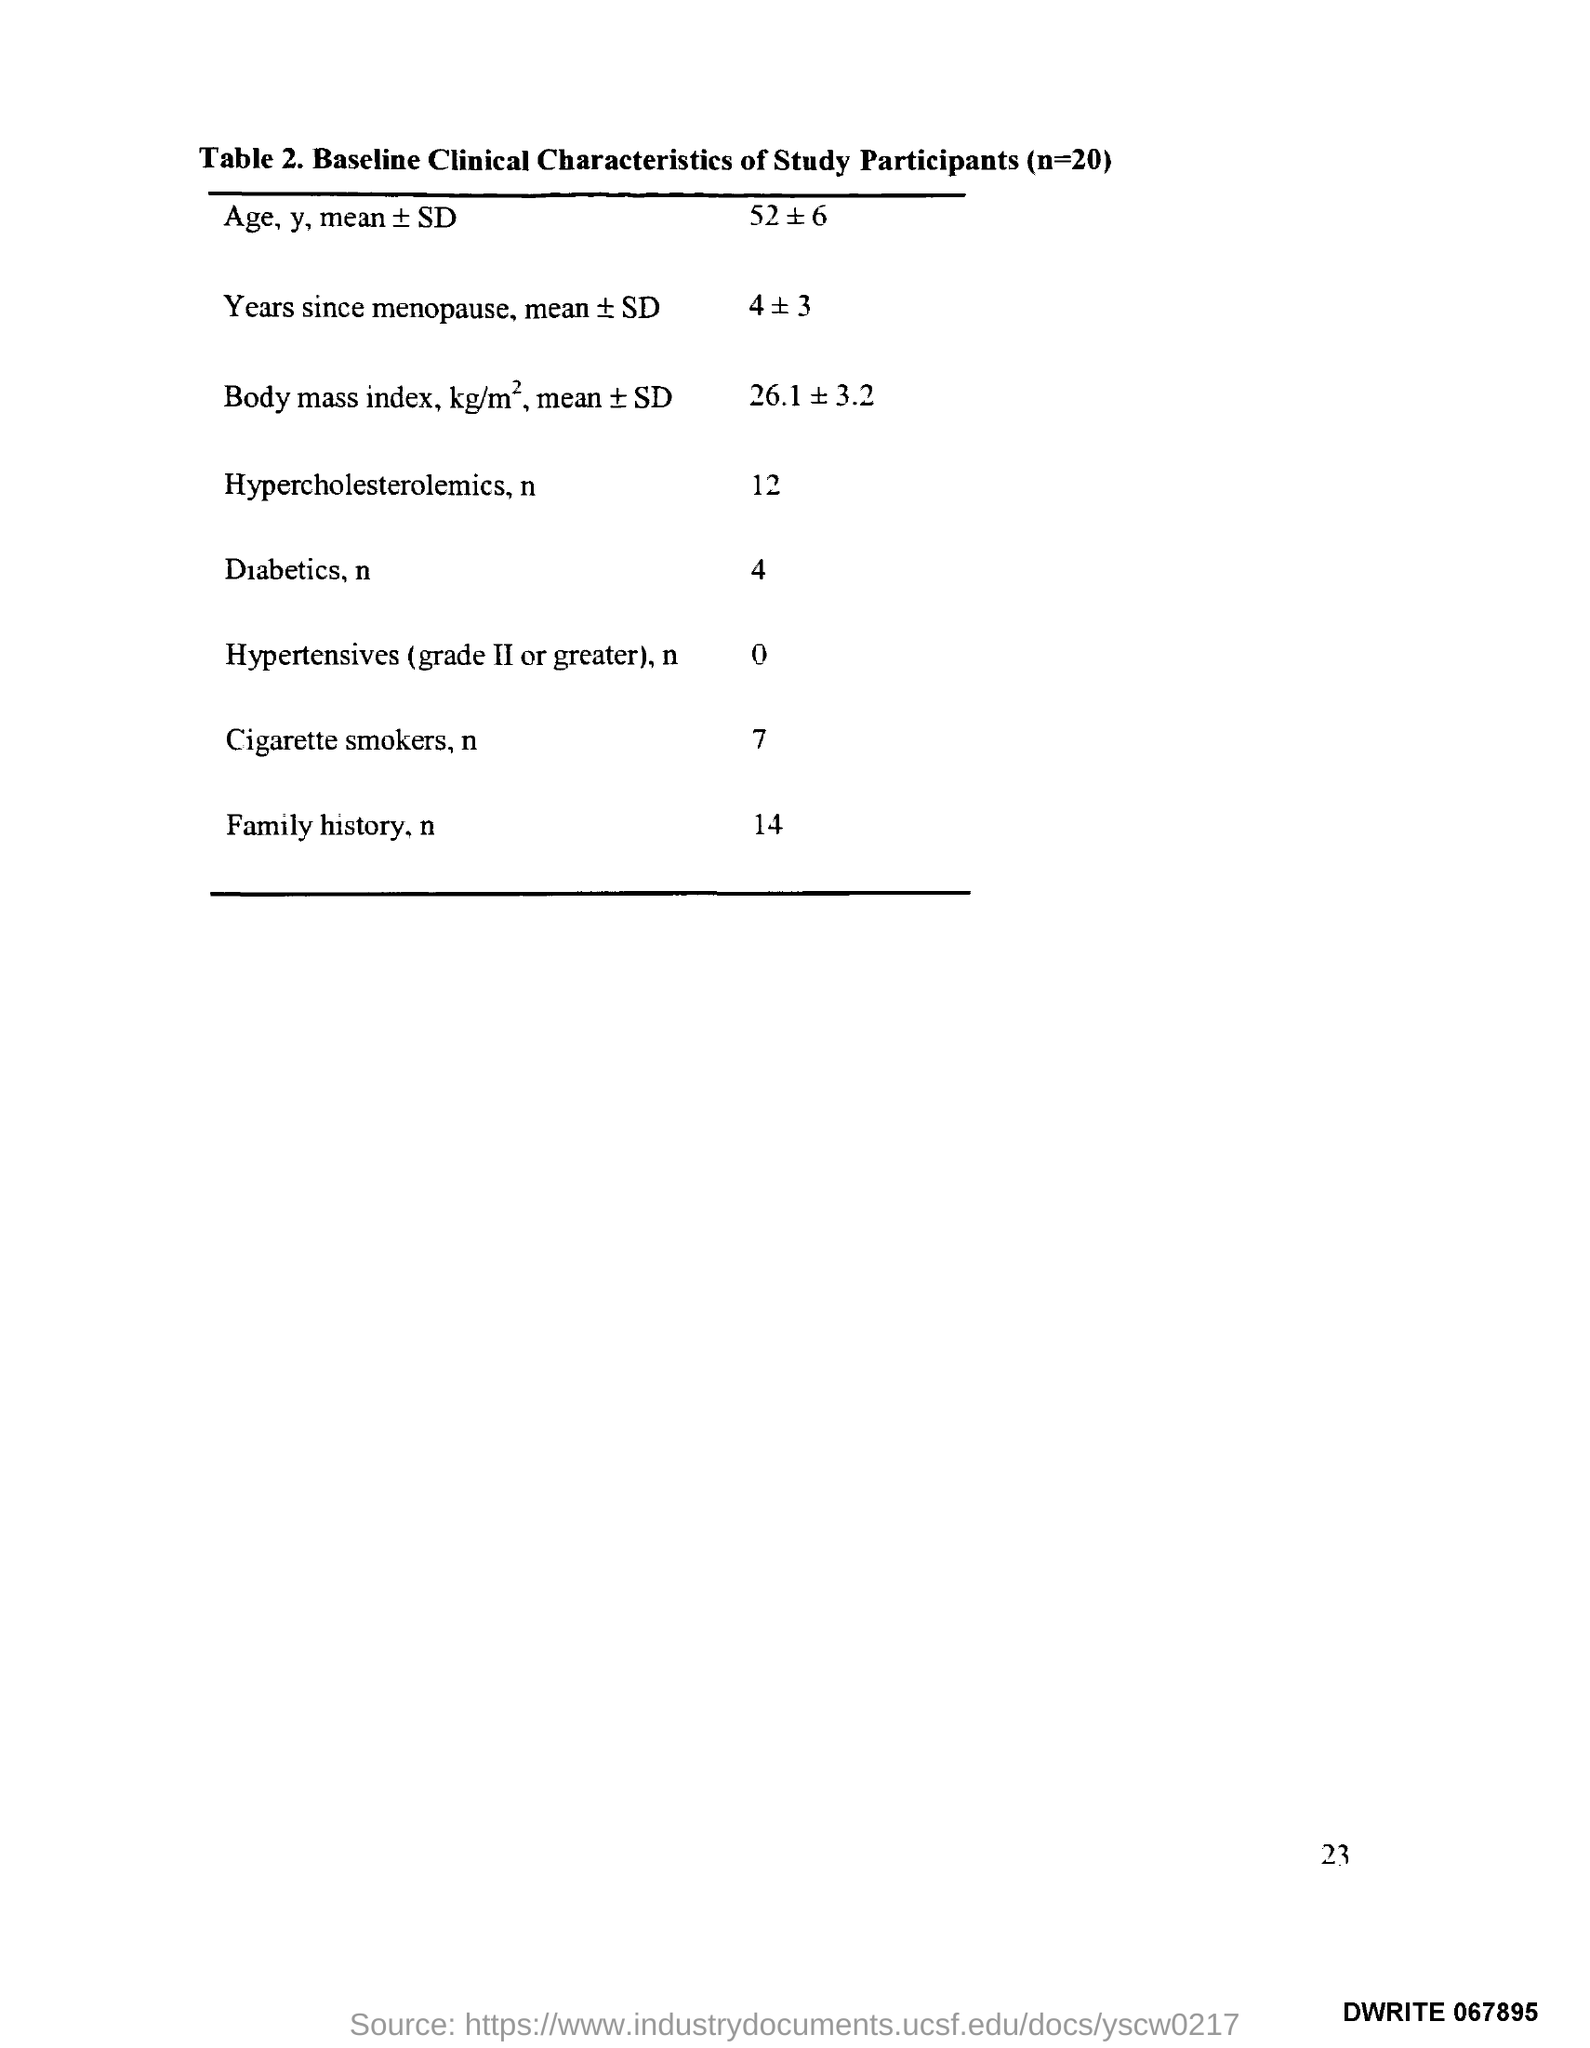What is the Page Number?
Offer a very short reply. 23. 